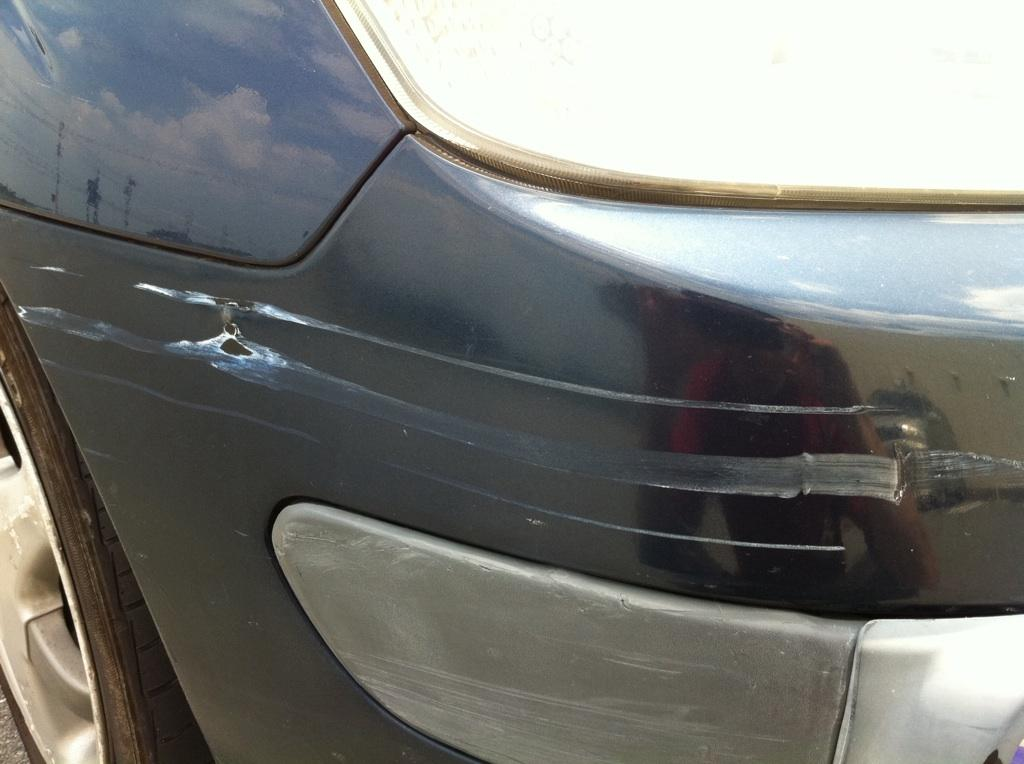What is the color of the car in the image? The car in the image is black. What are the wheels of the car called? The car has tyres. What are the lights on the front of the car called? The car has headlights. What is the rate of the car's speed in the image? The image does not provide information about the car's speed, so we cannot determine its rate. 